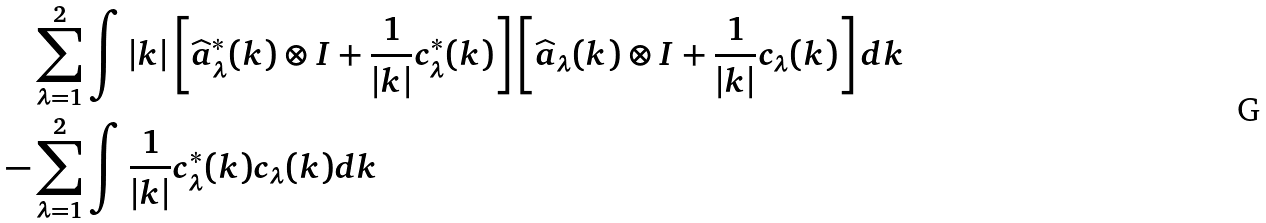Convert formula to latex. <formula><loc_0><loc_0><loc_500><loc_500>& \sum _ { \lambda = 1 } ^ { 2 } \int | k | \left [ \widehat { a } ^ { * } _ { \lambda } ( k ) \otimes I + \frac { 1 } { | k | } c ^ { * } _ { \lambda } ( k ) \right ] \left [ \widehat { a } _ { \lambda } ( k ) \otimes I + \frac { 1 } { | k | } c _ { \lambda } ( k ) \right ] d k \\ - & \sum _ { \lambda = 1 } ^ { 2 } \int \frac { 1 } { | k | } c ^ { * } _ { \lambda } ( k ) c _ { \lambda } ( k ) d k</formula> 